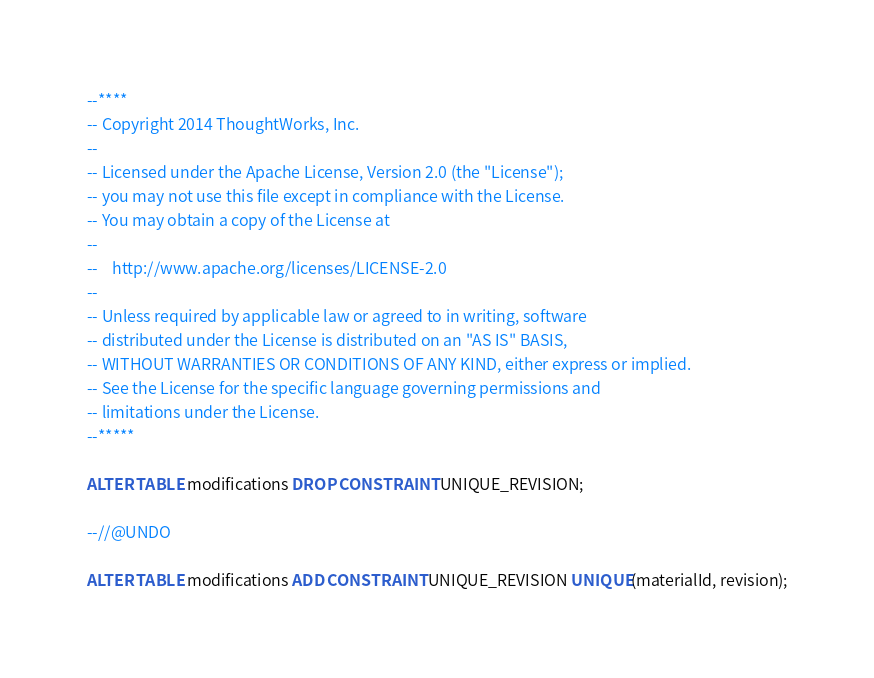<code> <loc_0><loc_0><loc_500><loc_500><_SQL_>--****
-- Copyright 2014 ThoughtWorks, Inc.
--
-- Licensed under the Apache License, Version 2.0 (the "License");
-- you may not use this file except in compliance with the License.
-- You may obtain a copy of the License at
--
--    http://www.apache.org/licenses/LICENSE-2.0
--
-- Unless required by applicable law or agreed to in writing, software
-- distributed under the License is distributed on an "AS IS" BASIS,
-- WITHOUT WARRANTIES OR CONDITIONS OF ANY KIND, either express or implied.
-- See the License for the specific language governing permissions and
-- limitations under the License.
--*****

ALTER TABLE modifications DROP CONSTRAINT UNIQUE_REVISION;

--//@UNDO

ALTER TABLE modifications ADD CONSTRAINT UNIQUE_REVISION UNIQUE(materialId, revision);
</code> 